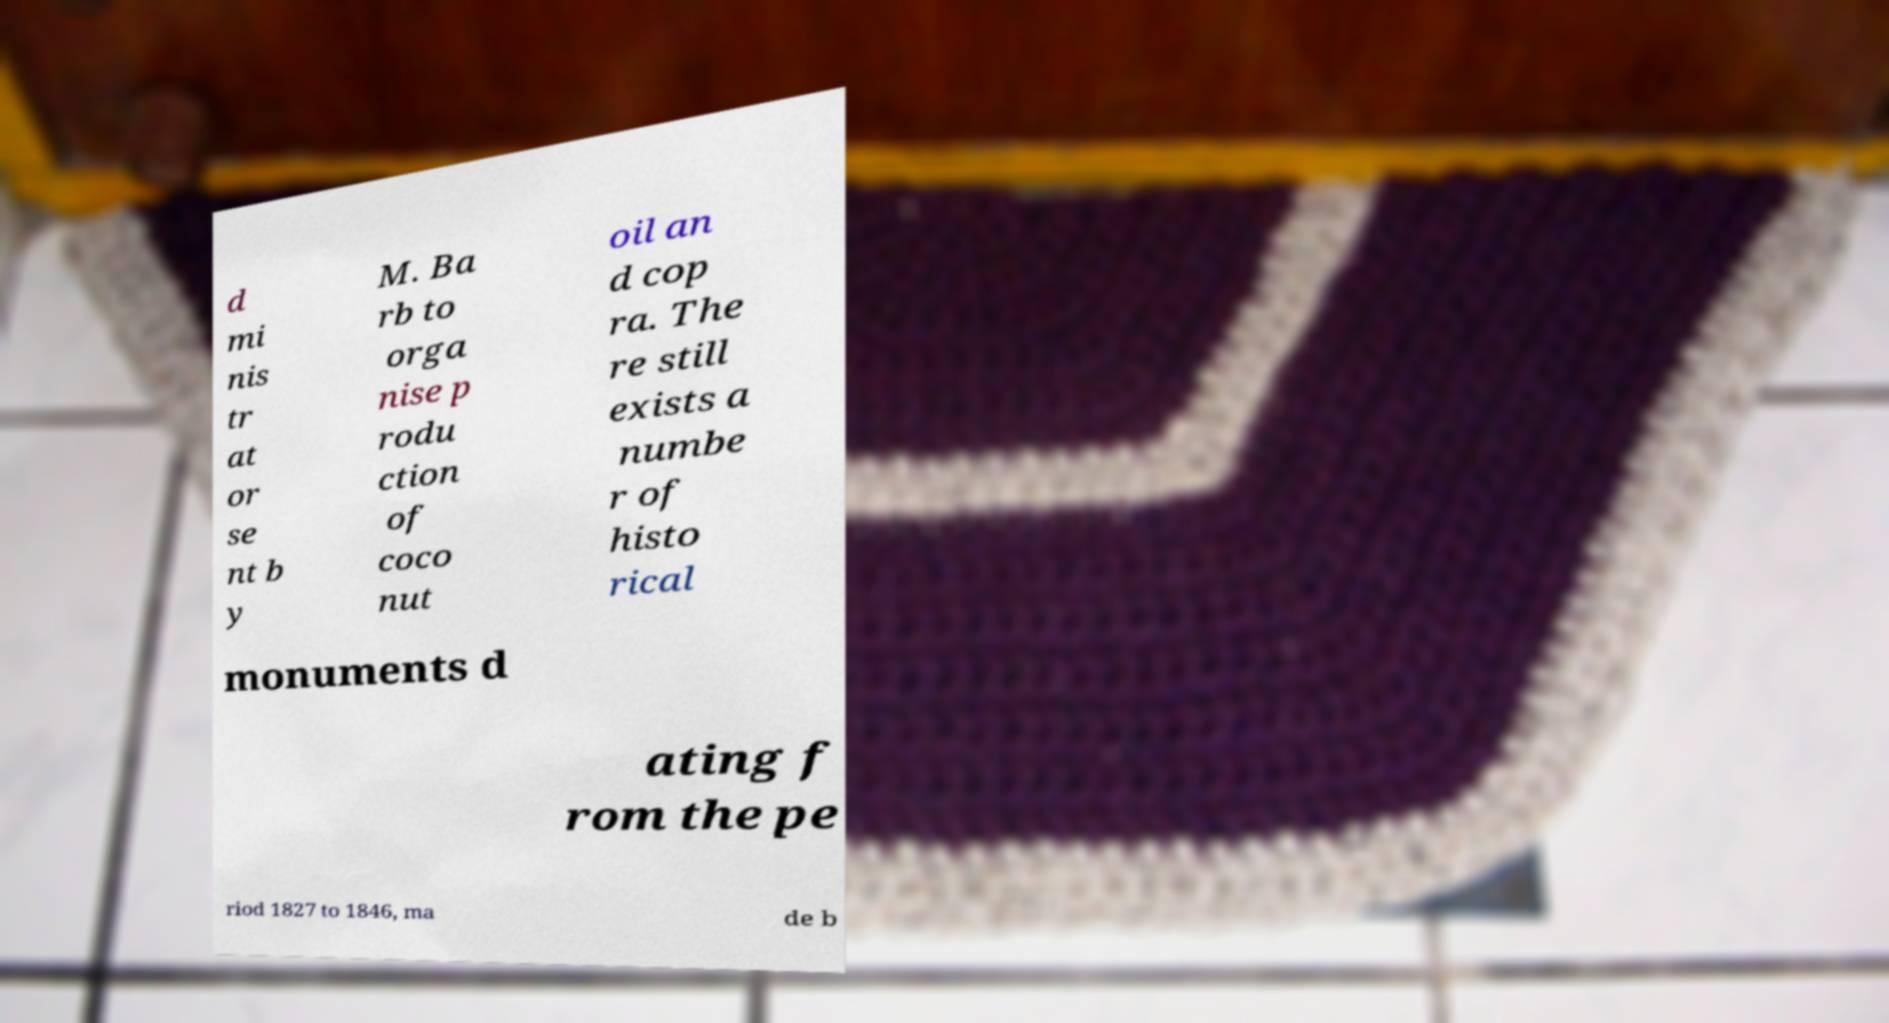Please read and relay the text visible in this image. What does it say? d mi nis tr at or se nt b y M. Ba rb to orga nise p rodu ction of coco nut oil an d cop ra. The re still exists a numbe r of histo rical monuments d ating f rom the pe riod 1827 to 1846, ma de b 